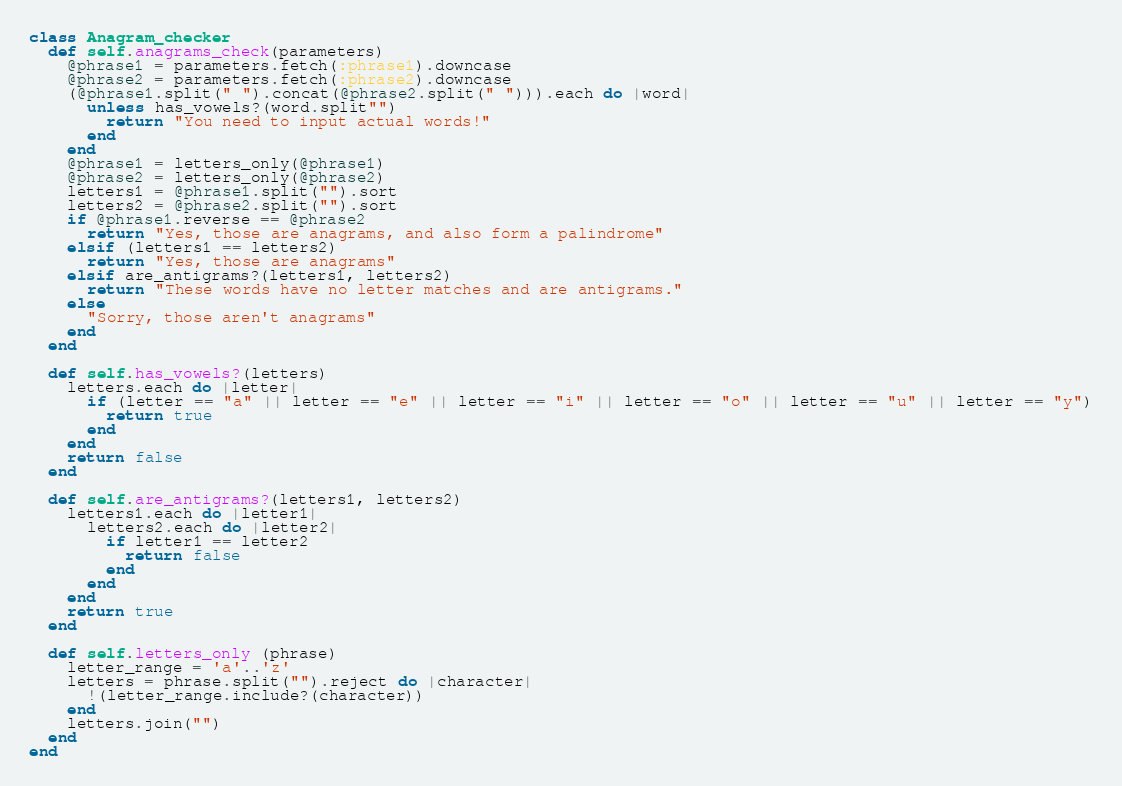<code> <loc_0><loc_0><loc_500><loc_500><_Ruby_>class Anagram_checker
  def self.anagrams_check(parameters)
    @phrase1 = parameters.fetch(:phrase1).downcase
    @phrase2 = parameters.fetch(:phrase2).downcase
    (@phrase1.split(" ").concat(@phrase2.split(" "))).each do |word|
      unless has_vowels?(word.split"")
        return "You need to input actual words!"
      end
    end
    @phrase1 = letters_only(@phrase1)
    @phrase2 = letters_only(@phrase2)
    letters1 = @phrase1.split("").sort
    letters2 = @phrase2.split("").sort
    if @phrase1.reverse == @phrase2
      return "Yes, those are anagrams, and also form a palindrome"
    elsif (letters1 == letters2)
      return "Yes, those are anagrams"
    elsif are_antigrams?(letters1, letters2)
      return "These words have no letter matches and are antigrams."
    else
      "Sorry, those aren't anagrams"
    end
  end

  def self.has_vowels?(letters)
    letters.each do |letter|
      if (letter == "a" || letter == "e" || letter == "i" || letter == "o" || letter == "u" || letter == "y")
        return true
      end
    end
    return false
  end

  def self.are_antigrams?(letters1, letters2)
    letters1.each do |letter1|
      letters2.each do |letter2|
        if letter1 == letter2
          return false
        end
      end
    end
    return true
  end

  def self.letters_only (phrase)
    letter_range = 'a'..'z'
    letters = phrase.split("").reject do |character|
      !(letter_range.include?(character))
    end
    letters.join("")
  end
end
</code> 